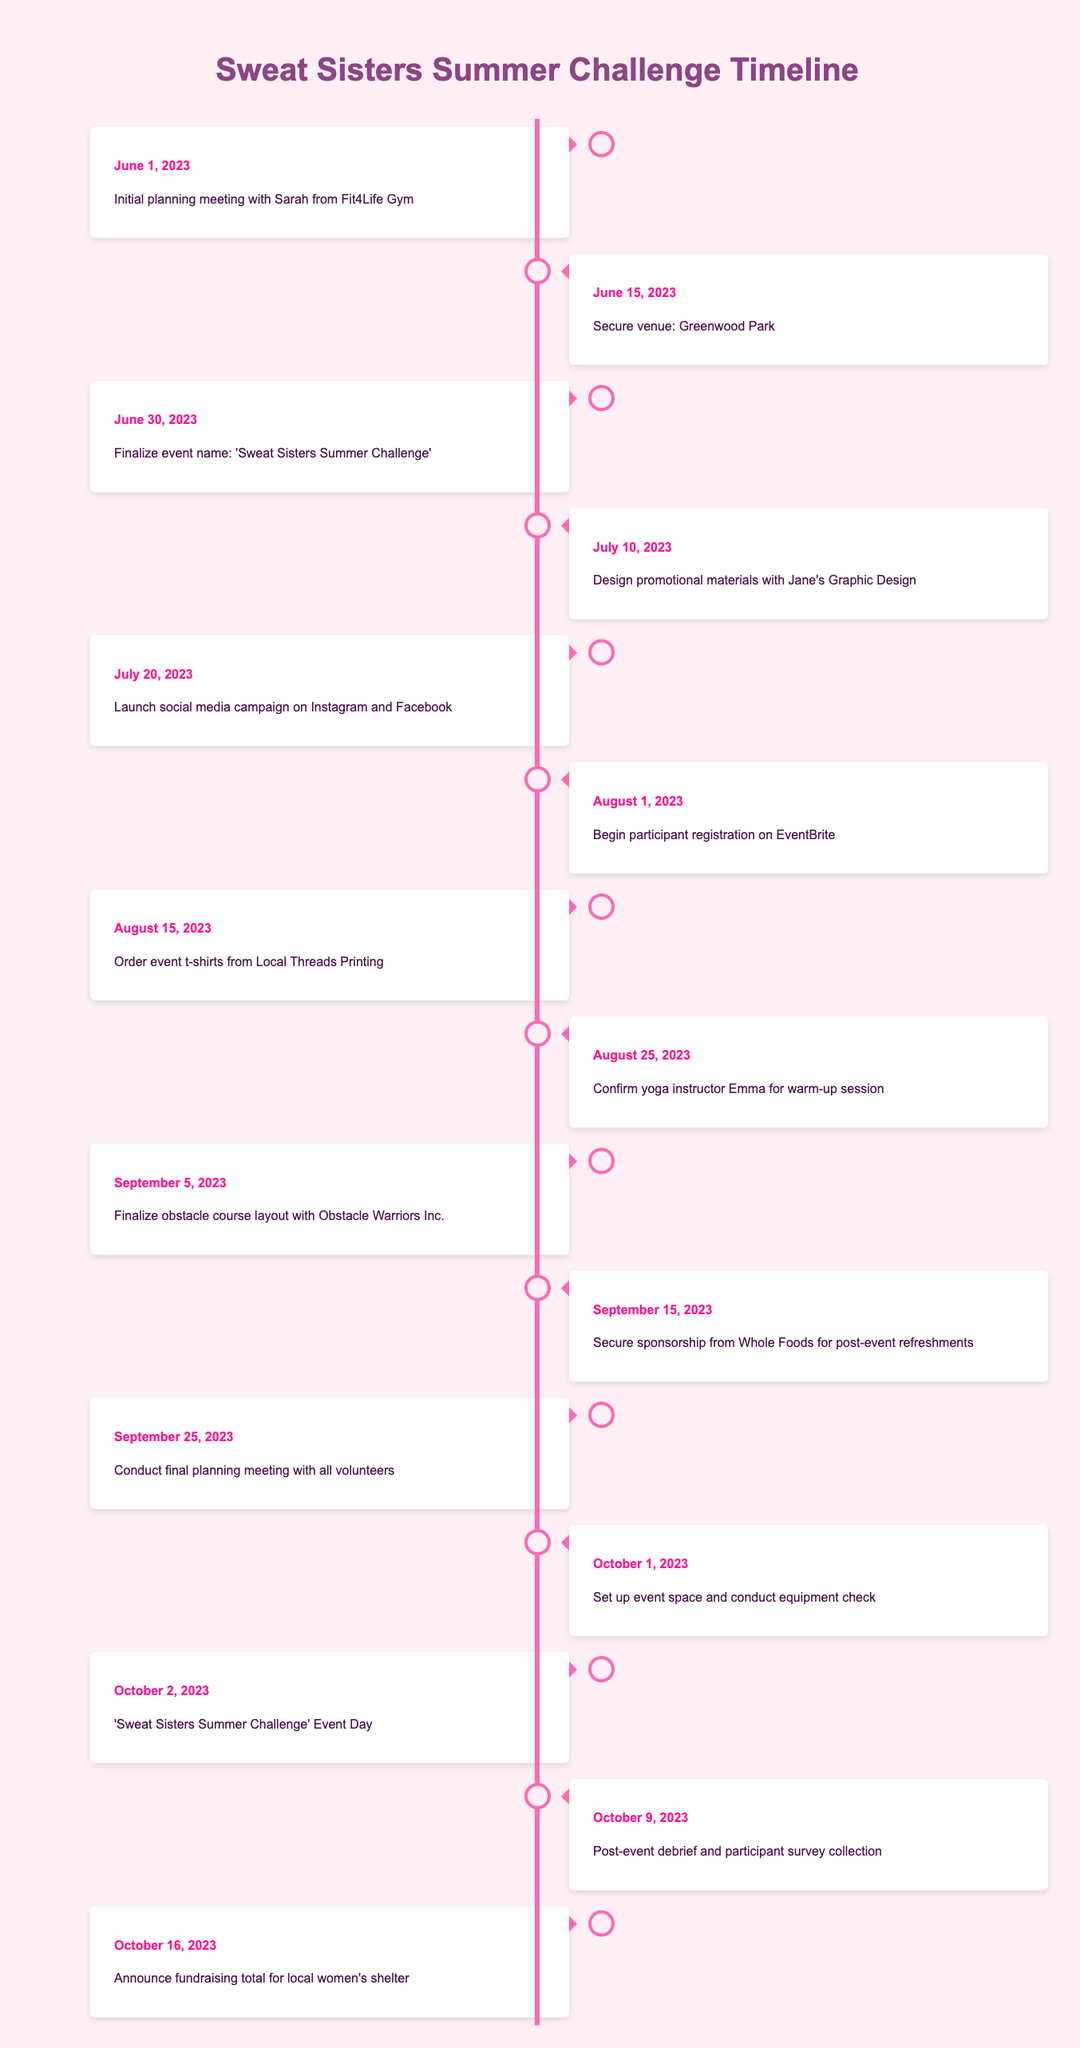What is the event name for the fitness challenge? The event name is listed in the timeline for June 30, 2023, where it states, "Finalize event name: 'Sweat Sisters Summer Challenge'".
Answer: Sweat Sisters Summer Challenge How many weeks are there between the initial planning meeting and the event day? The initial planning meeting is on June 1, 2023, and the event day is October 2, 2023. Counting the number of weeks between these two dates gives us approximately 17 weeks.
Answer: 17 weeks Was a yoga instructor confirmed before the event date? Yes, a yoga instructor named Emma was confirmed for the warm-up session on August 25, 2023, which is before the event day on October 2, 2023.
Answer: Yes What date marks the launch of the social media campaign? The launch of the social media campaign is specified in the timeline for July 20, 2023, as "Launch social media campaign on Instagram and Facebook".
Answer: July 20, 2023 How many days were there between ordering t-shirts and confirming the yoga instructor? The t-shirts were ordered on August 15, 2023, and the yoga instructor was confirmed on August 25, 2023. The difference is 10 days.
Answer: 10 days Which event had the last date in the timeline? The last event in the timeline is on October 16, 2023, which is stated as "Announce fundraising total for local women's shelter".
Answer: Announce fundraising total for local women's shelter Is the venue for the event secured before participant registration begins? Yes, the venue, Greenwood Park, was secured on June 15, 2023, and participant registration began on August 1, 2023, so the venue was secured beforehand.
Answer: Yes How many different organizations were involved in the preparation for the event? At least three organizations are mentioned: Fit4Life Gym, Jane's Graphic Design, and Whole Foods, among others. Therefore, a minimum of three different organizations were involved in the preparation.
Answer: At least three organizations 